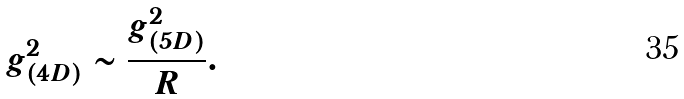Convert formula to latex. <formula><loc_0><loc_0><loc_500><loc_500>g _ { ( 4 D ) } ^ { 2 } \sim \frac { g _ { ( 5 D ) } ^ { 2 } } { R } .</formula> 